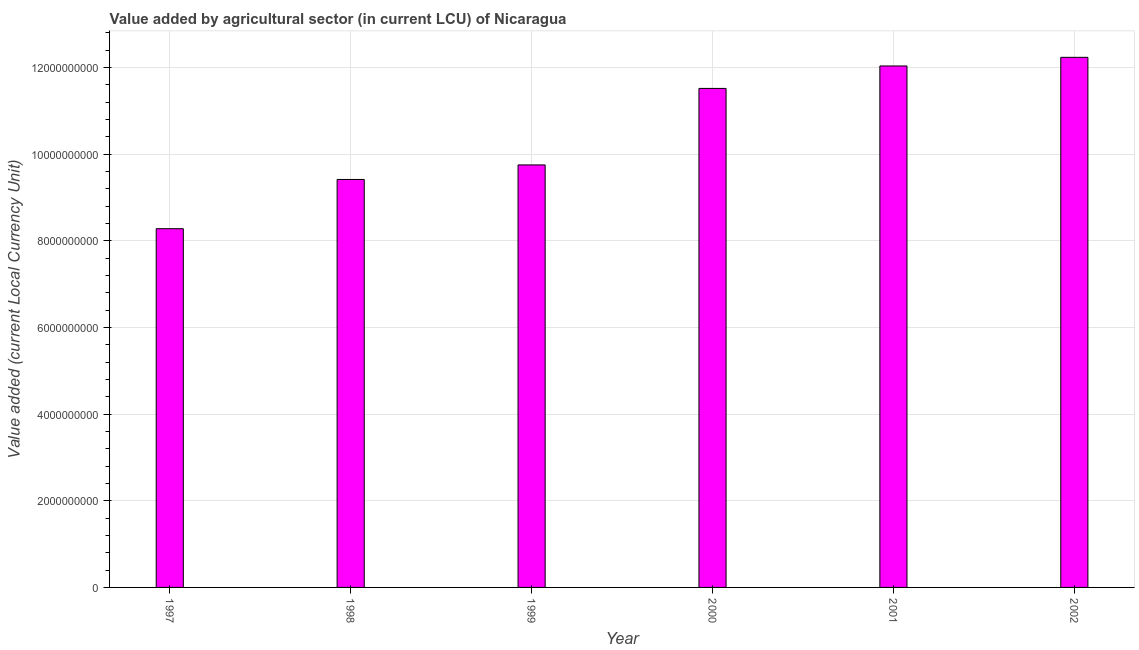Does the graph contain any zero values?
Your answer should be very brief. No. What is the title of the graph?
Your answer should be very brief. Value added by agricultural sector (in current LCU) of Nicaragua. What is the label or title of the X-axis?
Offer a very short reply. Year. What is the label or title of the Y-axis?
Your answer should be compact. Value added (current Local Currency Unit). What is the value added by agriculture sector in 2000?
Your answer should be very brief. 1.15e+1. Across all years, what is the maximum value added by agriculture sector?
Your response must be concise. 1.22e+1. Across all years, what is the minimum value added by agriculture sector?
Your answer should be very brief. 8.28e+09. In which year was the value added by agriculture sector maximum?
Make the answer very short. 2002. What is the sum of the value added by agriculture sector?
Give a very brief answer. 6.32e+1. What is the difference between the value added by agriculture sector in 1999 and 2001?
Your response must be concise. -2.28e+09. What is the average value added by agriculture sector per year?
Provide a succinct answer. 1.05e+1. What is the median value added by agriculture sector?
Give a very brief answer. 1.06e+1. In how many years, is the value added by agriculture sector greater than 2800000000 LCU?
Give a very brief answer. 6. What is the ratio of the value added by agriculture sector in 1997 to that in 2000?
Give a very brief answer. 0.72. What is the difference between the highest and the second highest value added by agriculture sector?
Your answer should be very brief. 1.99e+08. What is the difference between the highest and the lowest value added by agriculture sector?
Provide a succinct answer. 3.95e+09. In how many years, is the value added by agriculture sector greater than the average value added by agriculture sector taken over all years?
Make the answer very short. 3. What is the difference between two consecutive major ticks on the Y-axis?
Your response must be concise. 2.00e+09. What is the Value added (current Local Currency Unit) in 1997?
Make the answer very short. 8.28e+09. What is the Value added (current Local Currency Unit) in 1998?
Your answer should be very brief. 9.41e+09. What is the Value added (current Local Currency Unit) in 1999?
Make the answer very short. 9.75e+09. What is the Value added (current Local Currency Unit) in 2000?
Your answer should be very brief. 1.15e+1. What is the Value added (current Local Currency Unit) in 2001?
Make the answer very short. 1.20e+1. What is the Value added (current Local Currency Unit) of 2002?
Your answer should be very brief. 1.22e+1. What is the difference between the Value added (current Local Currency Unit) in 1997 and 1998?
Offer a terse response. -1.14e+09. What is the difference between the Value added (current Local Currency Unit) in 1997 and 1999?
Provide a succinct answer. -1.47e+09. What is the difference between the Value added (current Local Currency Unit) in 1997 and 2000?
Ensure brevity in your answer.  -3.24e+09. What is the difference between the Value added (current Local Currency Unit) in 1997 and 2001?
Provide a short and direct response. -3.75e+09. What is the difference between the Value added (current Local Currency Unit) in 1997 and 2002?
Your response must be concise. -3.95e+09. What is the difference between the Value added (current Local Currency Unit) in 1998 and 1999?
Provide a succinct answer. -3.36e+08. What is the difference between the Value added (current Local Currency Unit) in 1998 and 2000?
Make the answer very short. -2.10e+09. What is the difference between the Value added (current Local Currency Unit) in 1998 and 2001?
Give a very brief answer. -2.62e+09. What is the difference between the Value added (current Local Currency Unit) in 1998 and 2002?
Offer a very short reply. -2.82e+09. What is the difference between the Value added (current Local Currency Unit) in 1999 and 2000?
Your answer should be compact. -1.77e+09. What is the difference between the Value added (current Local Currency Unit) in 1999 and 2001?
Your answer should be compact. -2.28e+09. What is the difference between the Value added (current Local Currency Unit) in 1999 and 2002?
Keep it short and to the point. -2.48e+09. What is the difference between the Value added (current Local Currency Unit) in 2000 and 2001?
Make the answer very short. -5.18e+08. What is the difference between the Value added (current Local Currency Unit) in 2000 and 2002?
Your response must be concise. -7.17e+08. What is the difference between the Value added (current Local Currency Unit) in 2001 and 2002?
Ensure brevity in your answer.  -1.99e+08. What is the ratio of the Value added (current Local Currency Unit) in 1997 to that in 1998?
Offer a terse response. 0.88. What is the ratio of the Value added (current Local Currency Unit) in 1997 to that in 1999?
Your answer should be compact. 0.85. What is the ratio of the Value added (current Local Currency Unit) in 1997 to that in 2000?
Offer a terse response. 0.72. What is the ratio of the Value added (current Local Currency Unit) in 1997 to that in 2001?
Your response must be concise. 0.69. What is the ratio of the Value added (current Local Currency Unit) in 1997 to that in 2002?
Provide a short and direct response. 0.68. What is the ratio of the Value added (current Local Currency Unit) in 1998 to that in 1999?
Your answer should be very brief. 0.97. What is the ratio of the Value added (current Local Currency Unit) in 1998 to that in 2000?
Offer a very short reply. 0.82. What is the ratio of the Value added (current Local Currency Unit) in 1998 to that in 2001?
Offer a very short reply. 0.78. What is the ratio of the Value added (current Local Currency Unit) in 1998 to that in 2002?
Offer a very short reply. 0.77. What is the ratio of the Value added (current Local Currency Unit) in 1999 to that in 2000?
Your answer should be compact. 0.85. What is the ratio of the Value added (current Local Currency Unit) in 1999 to that in 2001?
Give a very brief answer. 0.81. What is the ratio of the Value added (current Local Currency Unit) in 1999 to that in 2002?
Your answer should be very brief. 0.8. What is the ratio of the Value added (current Local Currency Unit) in 2000 to that in 2002?
Provide a short and direct response. 0.94. 